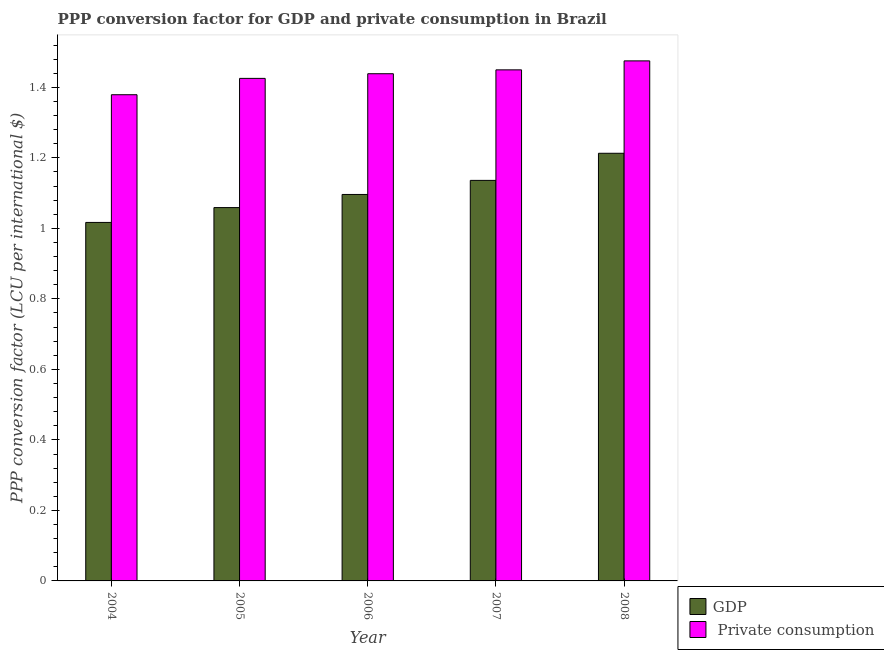How many different coloured bars are there?
Keep it short and to the point. 2. How many bars are there on the 3rd tick from the right?
Your response must be concise. 2. What is the label of the 4th group of bars from the left?
Your answer should be compact. 2007. In how many cases, is the number of bars for a given year not equal to the number of legend labels?
Provide a short and direct response. 0. What is the ppp conversion factor for gdp in 2007?
Ensure brevity in your answer.  1.14. Across all years, what is the maximum ppp conversion factor for private consumption?
Give a very brief answer. 1.48. Across all years, what is the minimum ppp conversion factor for gdp?
Offer a terse response. 1.02. In which year was the ppp conversion factor for private consumption maximum?
Provide a short and direct response. 2008. In which year was the ppp conversion factor for gdp minimum?
Your answer should be very brief. 2004. What is the total ppp conversion factor for gdp in the graph?
Ensure brevity in your answer.  5.52. What is the difference between the ppp conversion factor for gdp in 2004 and that in 2005?
Provide a succinct answer. -0.04. What is the difference between the ppp conversion factor for gdp in 2005 and the ppp conversion factor for private consumption in 2008?
Give a very brief answer. -0.15. What is the average ppp conversion factor for private consumption per year?
Give a very brief answer. 1.43. In the year 2008, what is the difference between the ppp conversion factor for private consumption and ppp conversion factor for gdp?
Your response must be concise. 0. In how many years, is the ppp conversion factor for gdp greater than 0.8 LCU?
Provide a succinct answer. 5. What is the ratio of the ppp conversion factor for private consumption in 2005 to that in 2007?
Your response must be concise. 0.98. Is the difference between the ppp conversion factor for gdp in 2007 and 2008 greater than the difference between the ppp conversion factor for private consumption in 2007 and 2008?
Your answer should be very brief. No. What is the difference between the highest and the second highest ppp conversion factor for gdp?
Offer a terse response. 0.08. What is the difference between the highest and the lowest ppp conversion factor for gdp?
Provide a short and direct response. 0.2. In how many years, is the ppp conversion factor for gdp greater than the average ppp conversion factor for gdp taken over all years?
Your answer should be very brief. 2. What does the 2nd bar from the left in 2007 represents?
Your answer should be compact.  Private consumption. What does the 1st bar from the right in 2005 represents?
Keep it short and to the point.  Private consumption. How many bars are there?
Offer a very short reply. 10. How many years are there in the graph?
Offer a terse response. 5. Are the values on the major ticks of Y-axis written in scientific E-notation?
Your answer should be very brief. No. Does the graph contain any zero values?
Offer a very short reply. No. Does the graph contain grids?
Your answer should be compact. No. Where does the legend appear in the graph?
Keep it short and to the point. Bottom right. How many legend labels are there?
Your response must be concise. 2. How are the legend labels stacked?
Offer a very short reply. Vertical. What is the title of the graph?
Offer a terse response. PPP conversion factor for GDP and private consumption in Brazil. Does "Forest land" appear as one of the legend labels in the graph?
Offer a terse response. No. What is the label or title of the X-axis?
Offer a very short reply. Year. What is the label or title of the Y-axis?
Provide a short and direct response. PPP conversion factor (LCU per international $). What is the PPP conversion factor (LCU per international $) of GDP in 2004?
Offer a terse response. 1.02. What is the PPP conversion factor (LCU per international $) of  Private consumption in 2004?
Your answer should be compact. 1.38. What is the PPP conversion factor (LCU per international $) of GDP in 2005?
Your answer should be very brief. 1.06. What is the PPP conversion factor (LCU per international $) in  Private consumption in 2005?
Your answer should be compact. 1.43. What is the PPP conversion factor (LCU per international $) of GDP in 2006?
Offer a terse response. 1.1. What is the PPP conversion factor (LCU per international $) of  Private consumption in 2006?
Your response must be concise. 1.44. What is the PPP conversion factor (LCU per international $) in GDP in 2007?
Your answer should be compact. 1.14. What is the PPP conversion factor (LCU per international $) of  Private consumption in 2007?
Make the answer very short. 1.45. What is the PPP conversion factor (LCU per international $) in GDP in 2008?
Keep it short and to the point. 1.21. What is the PPP conversion factor (LCU per international $) in  Private consumption in 2008?
Ensure brevity in your answer.  1.48. Across all years, what is the maximum PPP conversion factor (LCU per international $) in GDP?
Provide a succinct answer. 1.21. Across all years, what is the maximum PPP conversion factor (LCU per international $) of  Private consumption?
Give a very brief answer. 1.48. Across all years, what is the minimum PPP conversion factor (LCU per international $) of GDP?
Offer a very short reply. 1.02. Across all years, what is the minimum PPP conversion factor (LCU per international $) in  Private consumption?
Your answer should be very brief. 1.38. What is the total PPP conversion factor (LCU per international $) in GDP in the graph?
Make the answer very short. 5.52. What is the total PPP conversion factor (LCU per international $) in  Private consumption in the graph?
Offer a very short reply. 7.17. What is the difference between the PPP conversion factor (LCU per international $) in GDP in 2004 and that in 2005?
Your answer should be compact. -0.04. What is the difference between the PPP conversion factor (LCU per international $) in  Private consumption in 2004 and that in 2005?
Your answer should be compact. -0.05. What is the difference between the PPP conversion factor (LCU per international $) in GDP in 2004 and that in 2006?
Your answer should be very brief. -0.08. What is the difference between the PPP conversion factor (LCU per international $) in  Private consumption in 2004 and that in 2006?
Keep it short and to the point. -0.06. What is the difference between the PPP conversion factor (LCU per international $) in GDP in 2004 and that in 2007?
Your answer should be very brief. -0.12. What is the difference between the PPP conversion factor (LCU per international $) in  Private consumption in 2004 and that in 2007?
Provide a succinct answer. -0.07. What is the difference between the PPP conversion factor (LCU per international $) in GDP in 2004 and that in 2008?
Make the answer very short. -0.2. What is the difference between the PPP conversion factor (LCU per international $) in  Private consumption in 2004 and that in 2008?
Keep it short and to the point. -0.1. What is the difference between the PPP conversion factor (LCU per international $) in GDP in 2005 and that in 2006?
Your response must be concise. -0.04. What is the difference between the PPP conversion factor (LCU per international $) in  Private consumption in 2005 and that in 2006?
Keep it short and to the point. -0.01. What is the difference between the PPP conversion factor (LCU per international $) in GDP in 2005 and that in 2007?
Your answer should be compact. -0.08. What is the difference between the PPP conversion factor (LCU per international $) in  Private consumption in 2005 and that in 2007?
Your response must be concise. -0.02. What is the difference between the PPP conversion factor (LCU per international $) of GDP in 2005 and that in 2008?
Give a very brief answer. -0.15. What is the difference between the PPP conversion factor (LCU per international $) in  Private consumption in 2005 and that in 2008?
Give a very brief answer. -0.05. What is the difference between the PPP conversion factor (LCU per international $) in GDP in 2006 and that in 2007?
Provide a short and direct response. -0.04. What is the difference between the PPP conversion factor (LCU per international $) in  Private consumption in 2006 and that in 2007?
Offer a very short reply. -0.01. What is the difference between the PPP conversion factor (LCU per international $) of GDP in 2006 and that in 2008?
Your answer should be compact. -0.12. What is the difference between the PPP conversion factor (LCU per international $) of  Private consumption in 2006 and that in 2008?
Ensure brevity in your answer.  -0.04. What is the difference between the PPP conversion factor (LCU per international $) in GDP in 2007 and that in 2008?
Provide a succinct answer. -0.08. What is the difference between the PPP conversion factor (LCU per international $) in  Private consumption in 2007 and that in 2008?
Your answer should be very brief. -0.03. What is the difference between the PPP conversion factor (LCU per international $) of GDP in 2004 and the PPP conversion factor (LCU per international $) of  Private consumption in 2005?
Offer a very short reply. -0.41. What is the difference between the PPP conversion factor (LCU per international $) in GDP in 2004 and the PPP conversion factor (LCU per international $) in  Private consumption in 2006?
Give a very brief answer. -0.42. What is the difference between the PPP conversion factor (LCU per international $) of GDP in 2004 and the PPP conversion factor (LCU per international $) of  Private consumption in 2007?
Provide a short and direct response. -0.43. What is the difference between the PPP conversion factor (LCU per international $) in GDP in 2004 and the PPP conversion factor (LCU per international $) in  Private consumption in 2008?
Ensure brevity in your answer.  -0.46. What is the difference between the PPP conversion factor (LCU per international $) in GDP in 2005 and the PPP conversion factor (LCU per international $) in  Private consumption in 2006?
Offer a very short reply. -0.38. What is the difference between the PPP conversion factor (LCU per international $) of GDP in 2005 and the PPP conversion factor (LCU per international $) of  Private consumption in 2007?
Give a very brief answer. -0.39. What is the difference between the PPP conversion factor (LCU per international $) of GDP in 2005 and the PPP conversion factor (LCU per international $) of  Private consumption in 2008?
Make the answer very short. -0.42. What is the difference between the PPP conversion factor (LCU per international $) in GDP in 2006 and the PPP conversion factor (LCU per international $) in  Private consumption in 2007?
Offer a terse response. -0.35. What is the difference between the PPP conversion factor (LCU per international $) in GDP in 2006 and the PPP conversion factor (LCU per international $) in  Private consumption in 2008?
Ensure brevity in your answer.  -0.38. What is the difference between the PPP conversion factor (LCU per international $) in GDP in 2007 and the PPP conversion factor (LCU per international $) in  Private consumption in 2008?
Keep it short and to the point. -0.34. What is the average PPP conversion factor (LCU per international $) of GDP per year?
Your answer should be very brief. 1.1. What is the average PPP conversion factor (LCU per international $) in  Private consumption per year?
Keep it short and to the point. 1.43. In the year 2004, what is the difference between the PPP conversion factor (LCU per international $) in GDP and PPP conversion factor (LCU per international $) in  Private consumption?
Offer a very short reply. -0.36. In the year 2005, what is the difference between the PPP conversion factor (LCU per international $) of GDP and PPP conversion factor (LCU per international $) of  Private consumption?
Your answer should be compact. -0.37. In the year 2006, what is the difference between the PPP conversion factor (LCU per international $) of GDP and PPP conversion factor (LCU per international $) of  Private consumption?
Your response must be concise. -0.34. In the year 2007, what is the difference between the PPP conversion factor (LCU per international $) in GDP and PPP conversion factor (LCU per international $) in  Private consumption?
Provide a succinct answer. -0.31. In the year 2008, what is the difference between the PPP conversion factor (LCU per international $) of GDP and PPP conversion factor (LCU per international $) of  Private consumption?
Provide a succinct answer. -0.26. What is the ratio of the PPP conversion factor (LCU per international $) in GDP in 2004 to that in 2005?
Make the answer very short. 0.96. What is the ratio of the PPP conversion factor (LCU per international $) in  Private consumption in 2004 to that in 2005?
Your answer should be very brief. 0.97. What is the ratio of the PPP conversion factor (LCU per international $) in GDP in 2004 to that in 2006?
Your answer should be compact. 0.93. What is the ratio of the PPP conversion factor (LCU per international $) of  Private consumption in 2004 to that in 2006?
Your response must be concise. 0.96. What is the ratio of the PPP conversion factor (LCU per international $) in GDP in 2004 to that in 2007?
Provide a succinct answer. 0.9. What is the ratio of the PPP conversion factor (LCU per international $) of  Private consumption in 2004 to that in 2007?
Give a very brief answer. 0.95. What is the ratio of the PPP conversion factor (LCU per international $) of GDP in 2004 to that in 2008?
Make the answer very short. 0.84. What is the ratio of the PPP conversion factor (LCU per international $) of  Private consumption in 2004 to that in 2008?
Offer a terse response. 0.93. What is the ratio of the PPP conversion factor (LCU per international $) in GDP in 2005 to that in 2006?
Your answer should be compact. 0.97. What is the ratio of the PPP conversion factor (LCU per international $) of GDP in 2005 to that in 2007?
Your response must be concise. 0.93. What is the ratio of the PPP conversion factor (LCU per international $) of  Private consumption in 2005 to that in 2007?
Your answer should be compact. 0.98. What is the ratio of the PPP conversion factor (LCU per international $) in GDP in 2005 to that in 2008?
Offer a very short reply. 0.87. What is the ratio of the PPP conversion factor (LCU per international $) in  Private consumption in 2005 to that in 2008?
Make the answer very short. 0.97. What is the ratio of the PPP conversion factor (LCU per international $) in GDP in 2006 to that in 2007?
Offer a very short reply. 0.96. What is the ratio of the PPP conversion factor (LCU per international $) of  Private consumption in 2006 to that in 2007?
Keep it short and to the point. 0.99. What is the ratio of the PPP conversion factor (LCU per international $) of GDP in 2006 to that in 2008?
Keep it short and to the point. 0.9. What is the ratio of the PPP conversion factor (LCU per international $) of  Private consumption in 2006 to that in 2008?
Your answer should be very brief. 0.98. What is the ratio of the PPP conversion factor (LCU per international $) in GDP in 2007 to that in 2008?
Provide a short and direct response. 0.94. What is the ratio of the PPP conversion factor (LCU per international $) in  Private consumption in 2007 to that in 2008?
Provide a short and direct response. 0.98. What is the difference between the highest and the second highest PPP conversion factor (LCU per international $) of GDP?
Offer a terse response. 0.08. What is the difference between the highest and the second highest PPP conversion factor (LCU per international $) in  Private consumption?
Offer a very short reply. 0.03. What is the difference between the highest and the lowest PPP conversion factor (LCU per international $) in GDP?
Give a very brief answer. 0.2. What is the difference between the highest and the lowest PPP conversion factor (LCU per international $) in  Private consumption?
Your answer should be very brief. 0.1. 